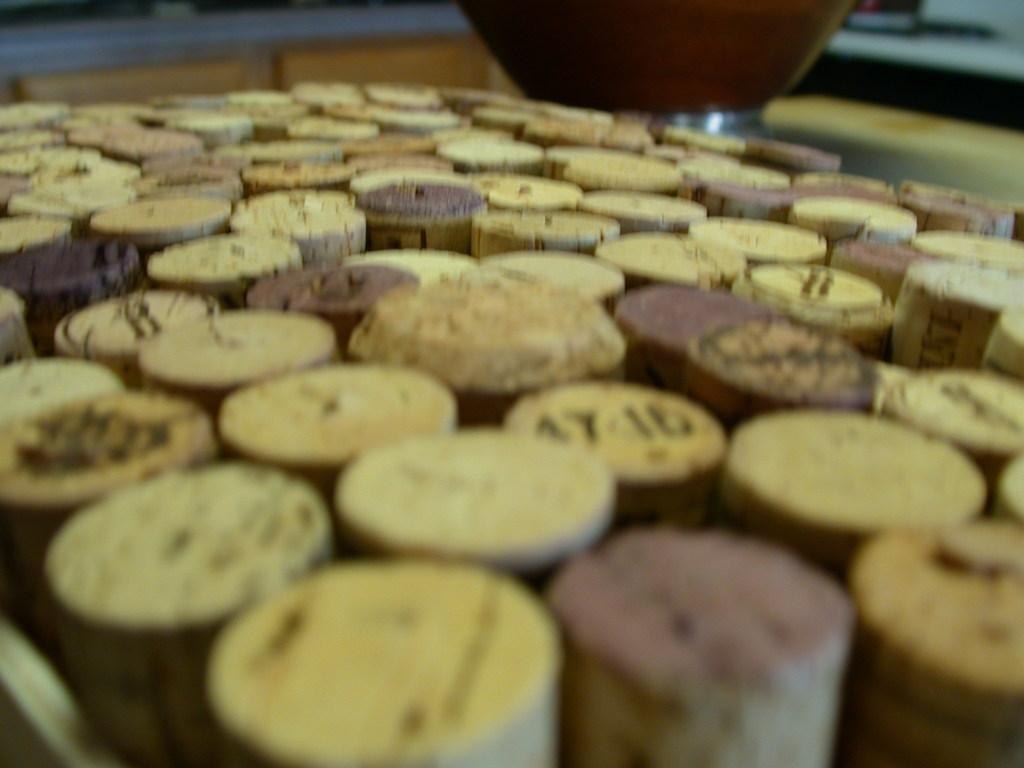What is the primary subject in the image? There are many corks in the image. Can you tell me how much tax the queen pays on the corks in the image? There is no information about tax or the queen in the image, as it only features many corks. 